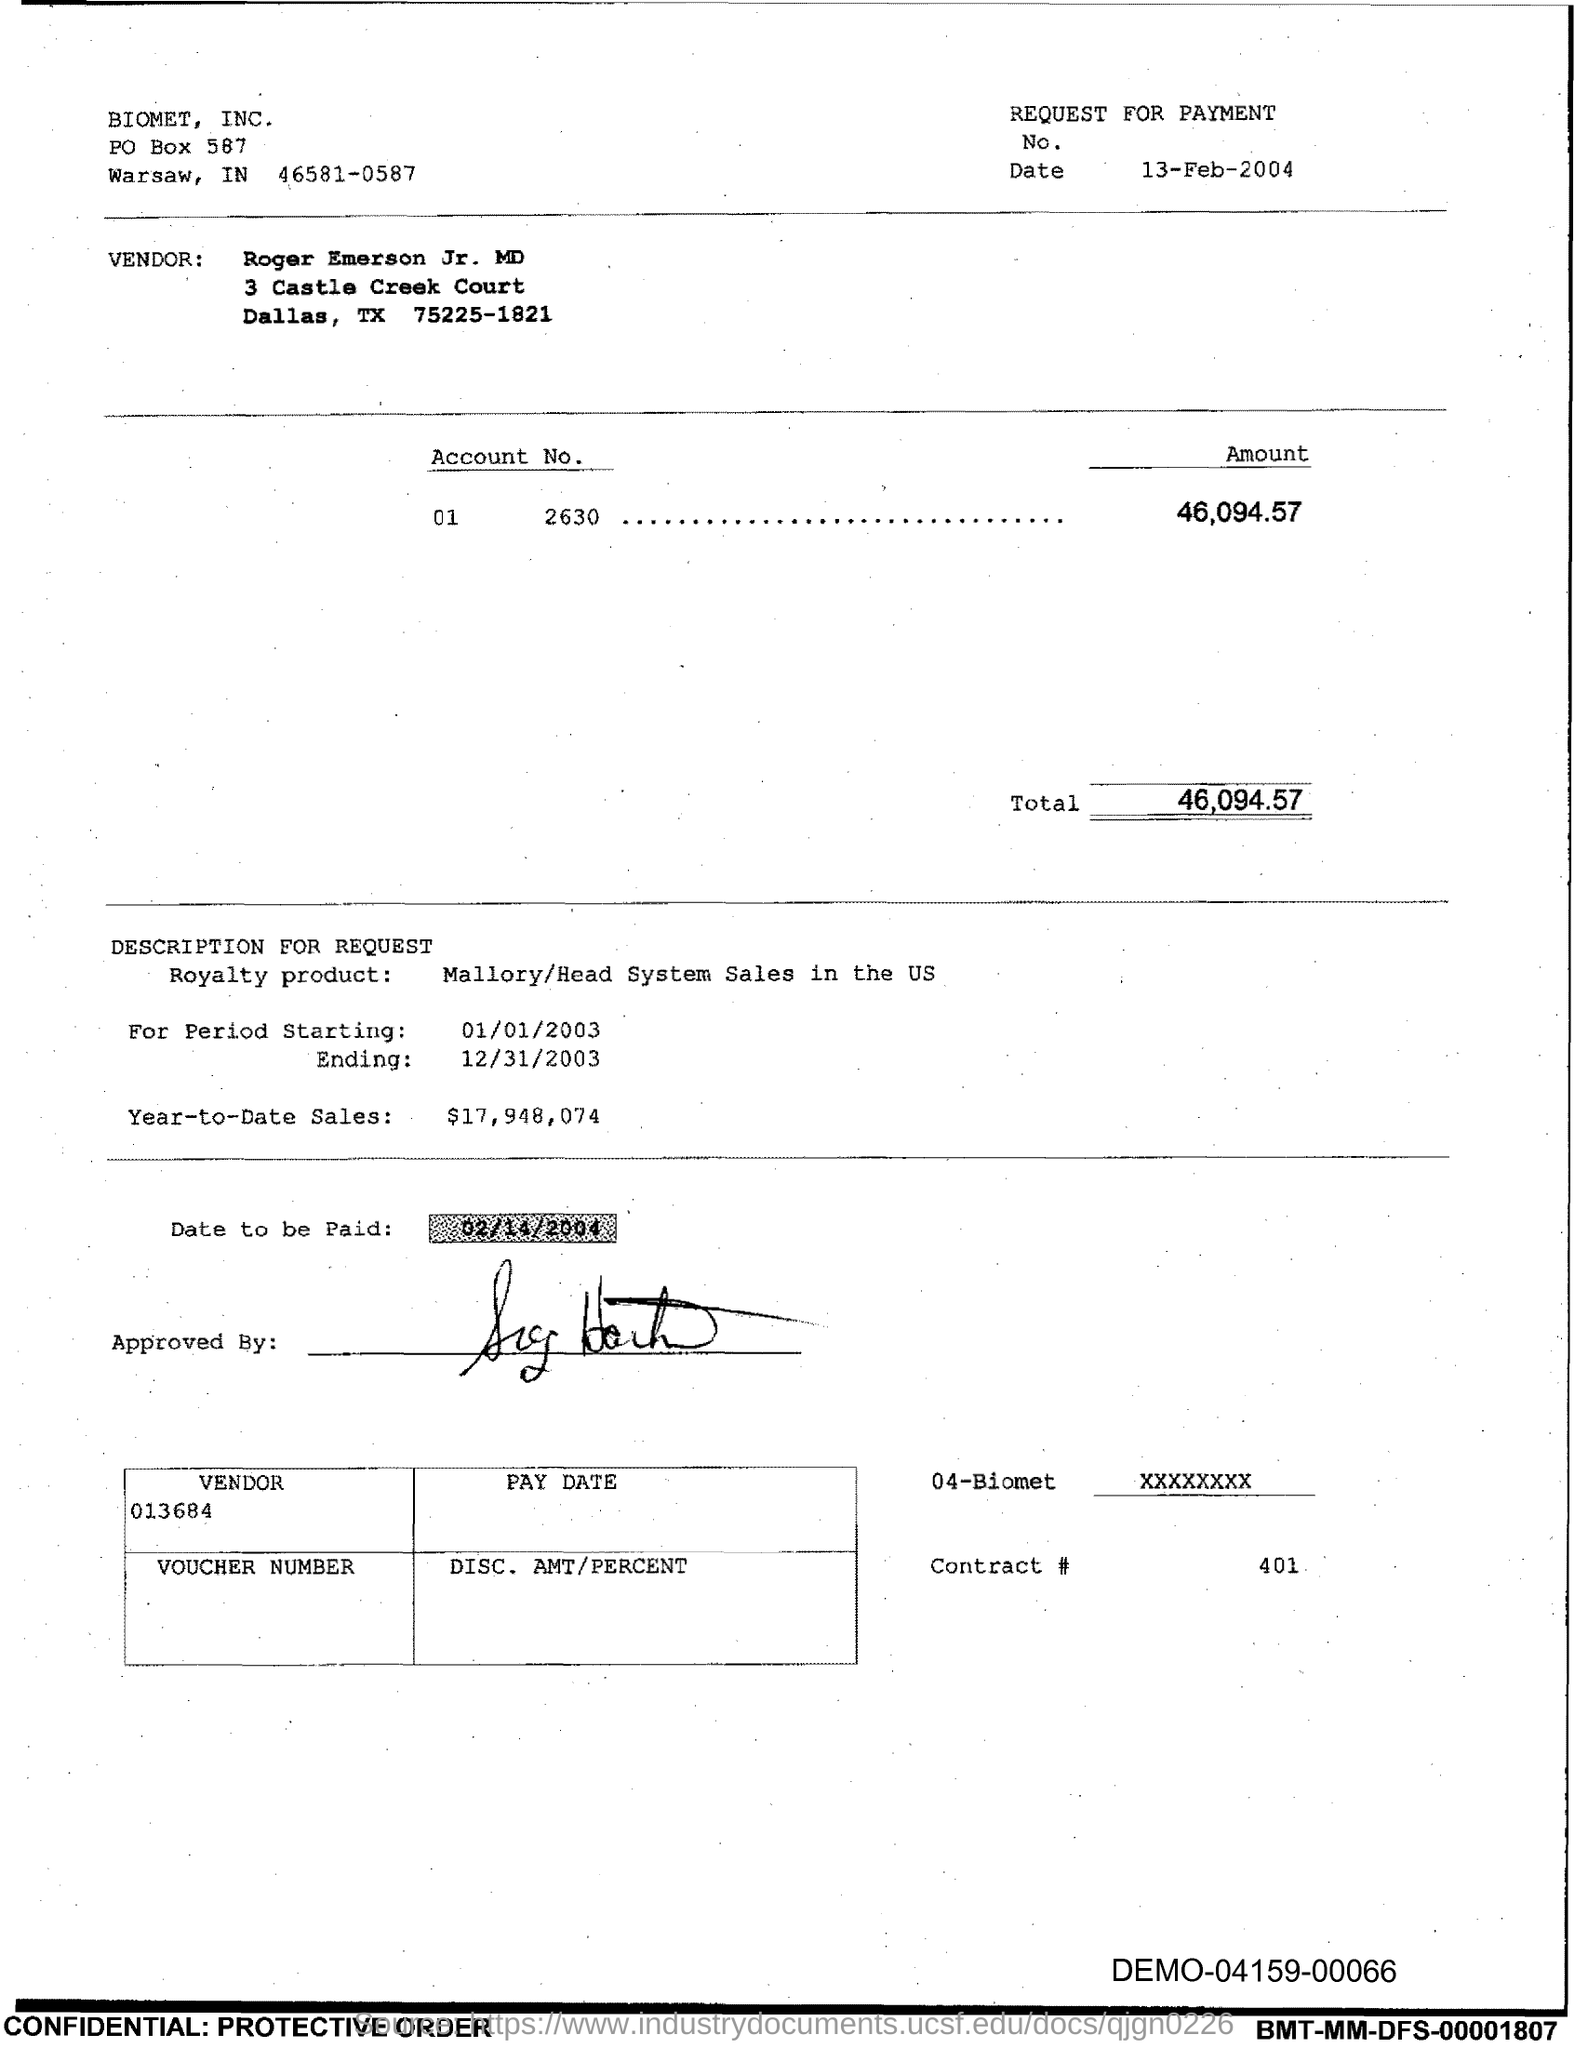Highlight a few significant elements in this photo. What is Contract #401?" is a question that asks for information about a specific contract, specifically its number. The PO Box number mentioned in the document is 587. The total is 46,094.57 dollars. On what date is the payment to be made? The date to be paid is 02/14/2004. 